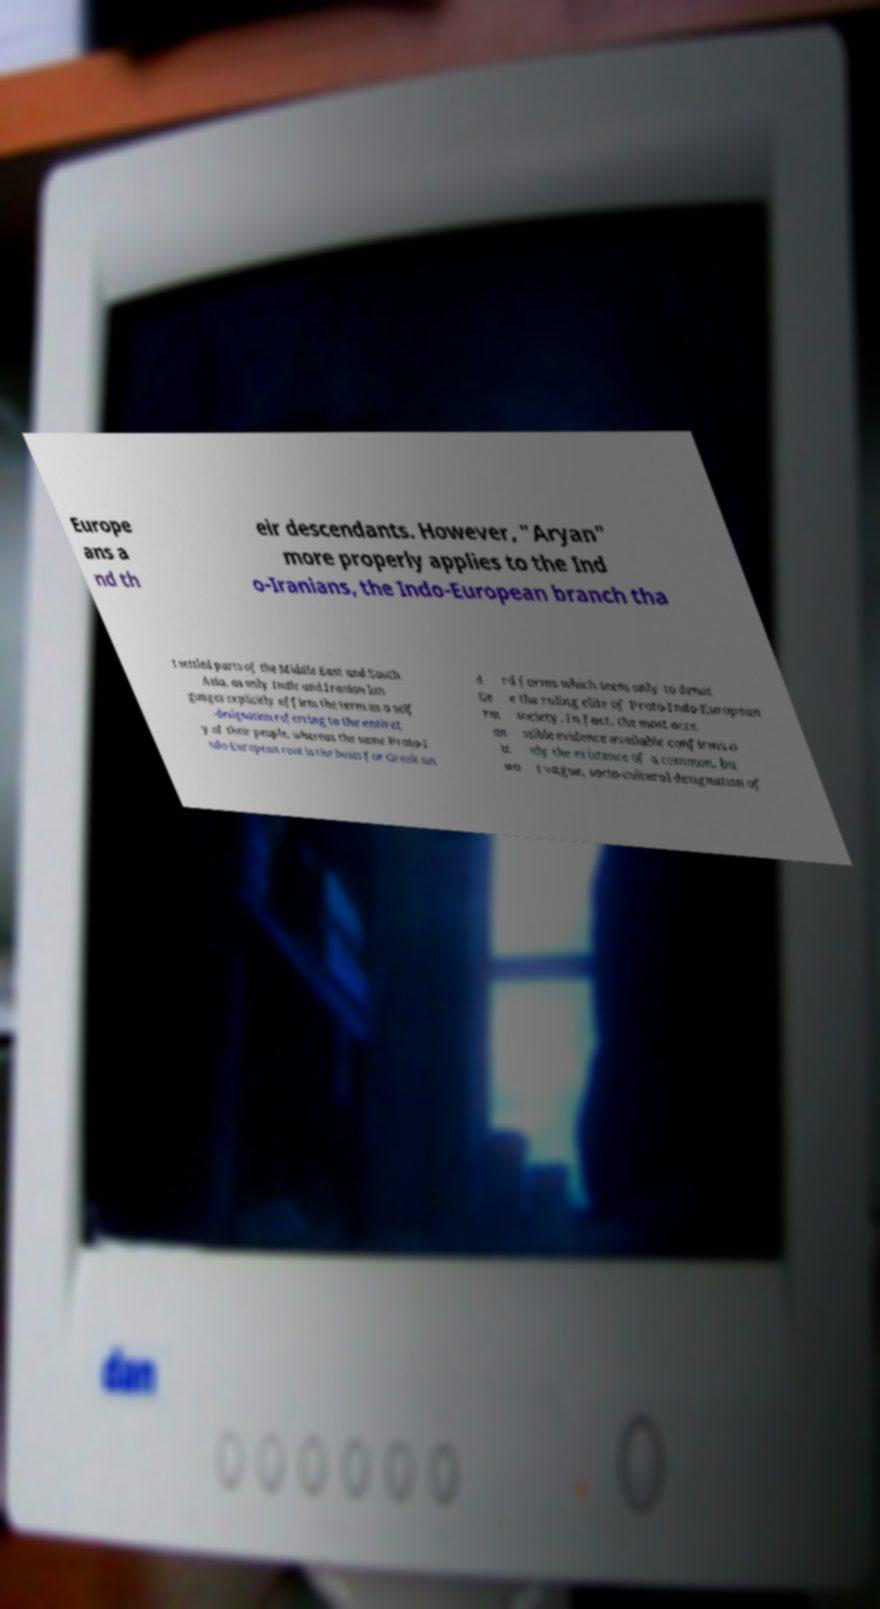Can you accurately transcribe the text from the provided image for me? Europe ans a nd th eir descendants. However, "Aryan" more properly applies to the Ind o-Iranians, the Indo-European branch tha t settled parts of the Middle East and South Asia, as only Indic and Iranian lan guages explicitly affirm the term as a self -designation referring to the entiret y of their people, whereas the same Proto-I ndo-European root is the basis for Greek an d Ge rm an ic wo rd forms which seem only to denot e the ruling elite of Proto-Indo-European society. In fact, the most acce ssible evidence available confirms o nly the existence of a common, bu t vague, socio-cultural designation of 